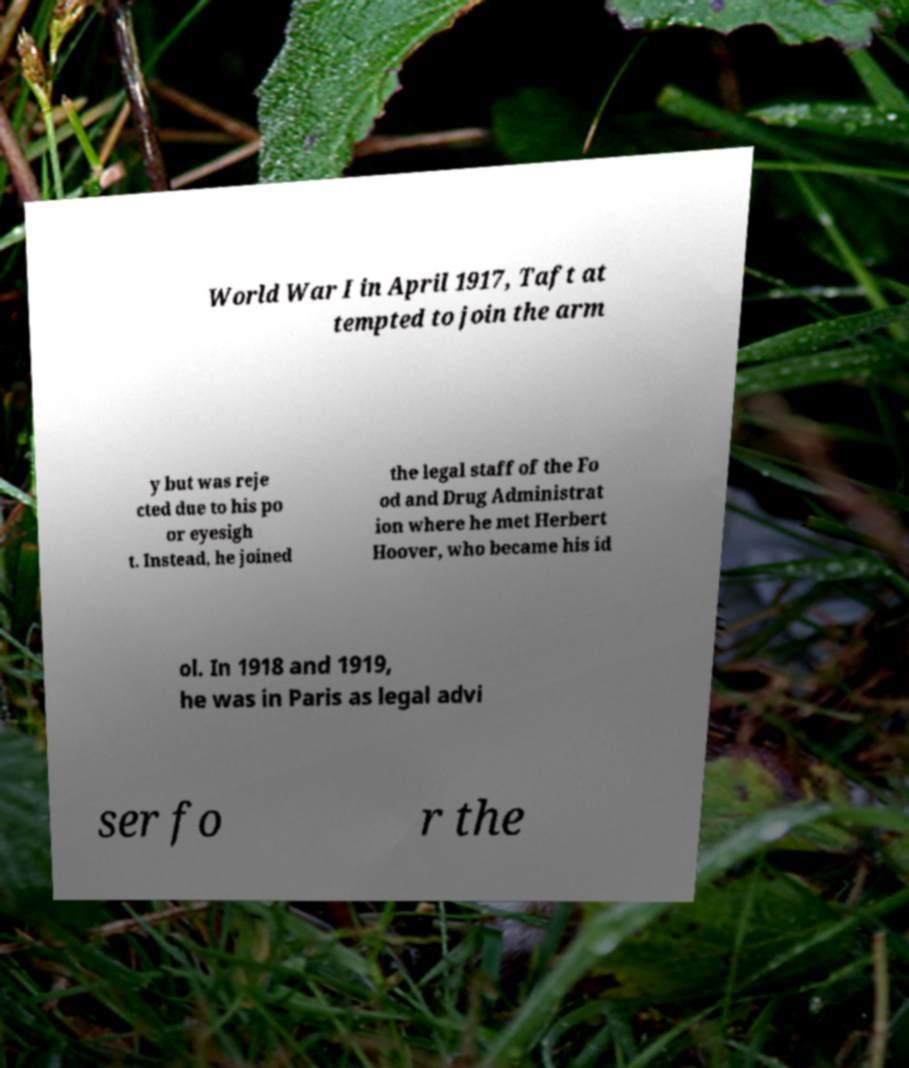Please identify and transcribe the text found in this image. World War I in April 1917, Taft at tempted to join the arm y but was reje cted due to his po or eyesigh t. Instead, he joined the legal staff of the Fo od and Drug Administrat ion where he met Herbert Hoover, who became his id ol. In 1918 and 1919, he was in Paris as legal advi ser fo r the 